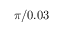Convert formula to latex. <formula><loc_0><loc_0><loc_500><loc_500>\pi / 0 . 0 3</formula> 